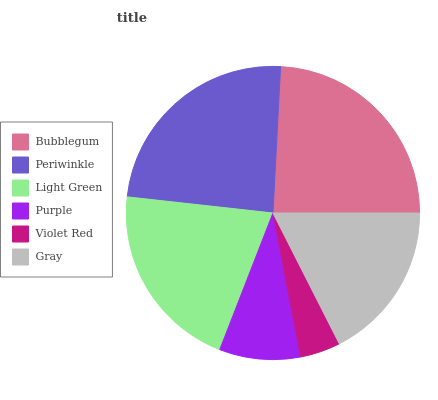Is Violet Red the minimum?
Answer yes or no. Yes. Is Bubblegum the maximum?
Answer yes or no. Yes. Is Periwinkle the minimum?
Answer yes or no. No. Is Periwinkle the maximum?
Answer yes or no. No. Is Bubblegum greater than Periwinkle?
Answer yes or no. Yes. Is Periwinkle less than Bubblegum?
Answer yes or no. Yes. Is Periwinkle greater than Bubblegum?
Answer yes or no. No. Is Bubblegum less than Periwinkle?
Answer yes or no. No. Is Light Green the high median?
Answer yes or no. Yes. Is Gray the low median?
Answer yes or no. Yes. Is Purple the high median?
Answer yes or no. No. Is Light Green the low median?
Answer yes or no. No. 